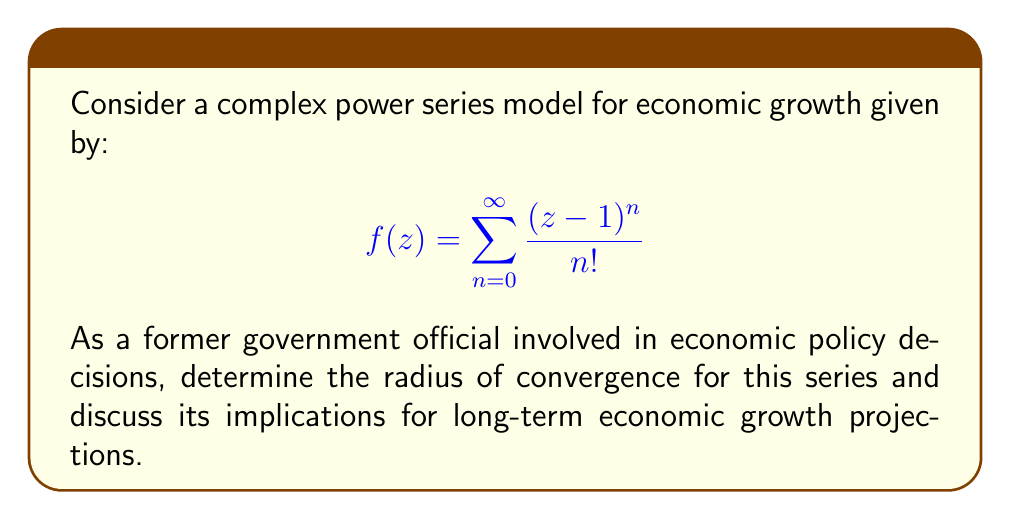Help me with this question. To analyze the convergence of this complex power series, we'll use the ratio test:

1) First, let's define the general term of the series:
   $$a_n = \frac{(z-1)^n}{n!}$$

2) Apply the ratio test:
   $$\lim_{n \to \infty} \left|\frac{a_{n+1}}{a_n}\right| = \lim_{n \to \infty} \left|\frac{(z-1)^{n+1}/(n+1)!}{(z-1)^n/n!}\right|$$

3) Simplify:
   $$\lim_{n \to \infty} \left|\frac{(z-1)^{n+1}}{(z-1)^n} \cdot \frac{n!}{(n+1)!}\right| = \lim_{n \to \infty} \left|z-1\right| \cdot \frac{1}{n+1}$$

4) Evaluate the limit:
   $$\lim_{n \to \infty} \left|z-1\right| \cdot \frac{1}{n+1} = 0$$

5) Since the limit is 0 (which is less than 1), the series converges for all complex values of z.

The radius of convergence is therefore infinite, which in economic terms implies that this model predicts stable growth patterns regardless of the scale of the economy (represented by |z-1|).

For policy-making, this suggests that the economic growth model is robust and can be applied to economies of various sizes without losing its predictive power. However, it's important to note that while mathematically sound, real-world economic systems often have limiting factors that aren't captured in this idealized model.
Answer: The radius of convergence for the given complex power series is infinite. The series converges for all complex values of z. 